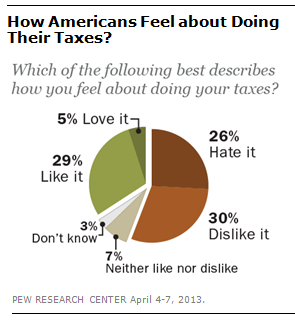Draw attention to some important aspects in this diagram. The color of the second largest segment is green. The ratio of the largest segment to the second smallest segment is approximately 0.250694444... 